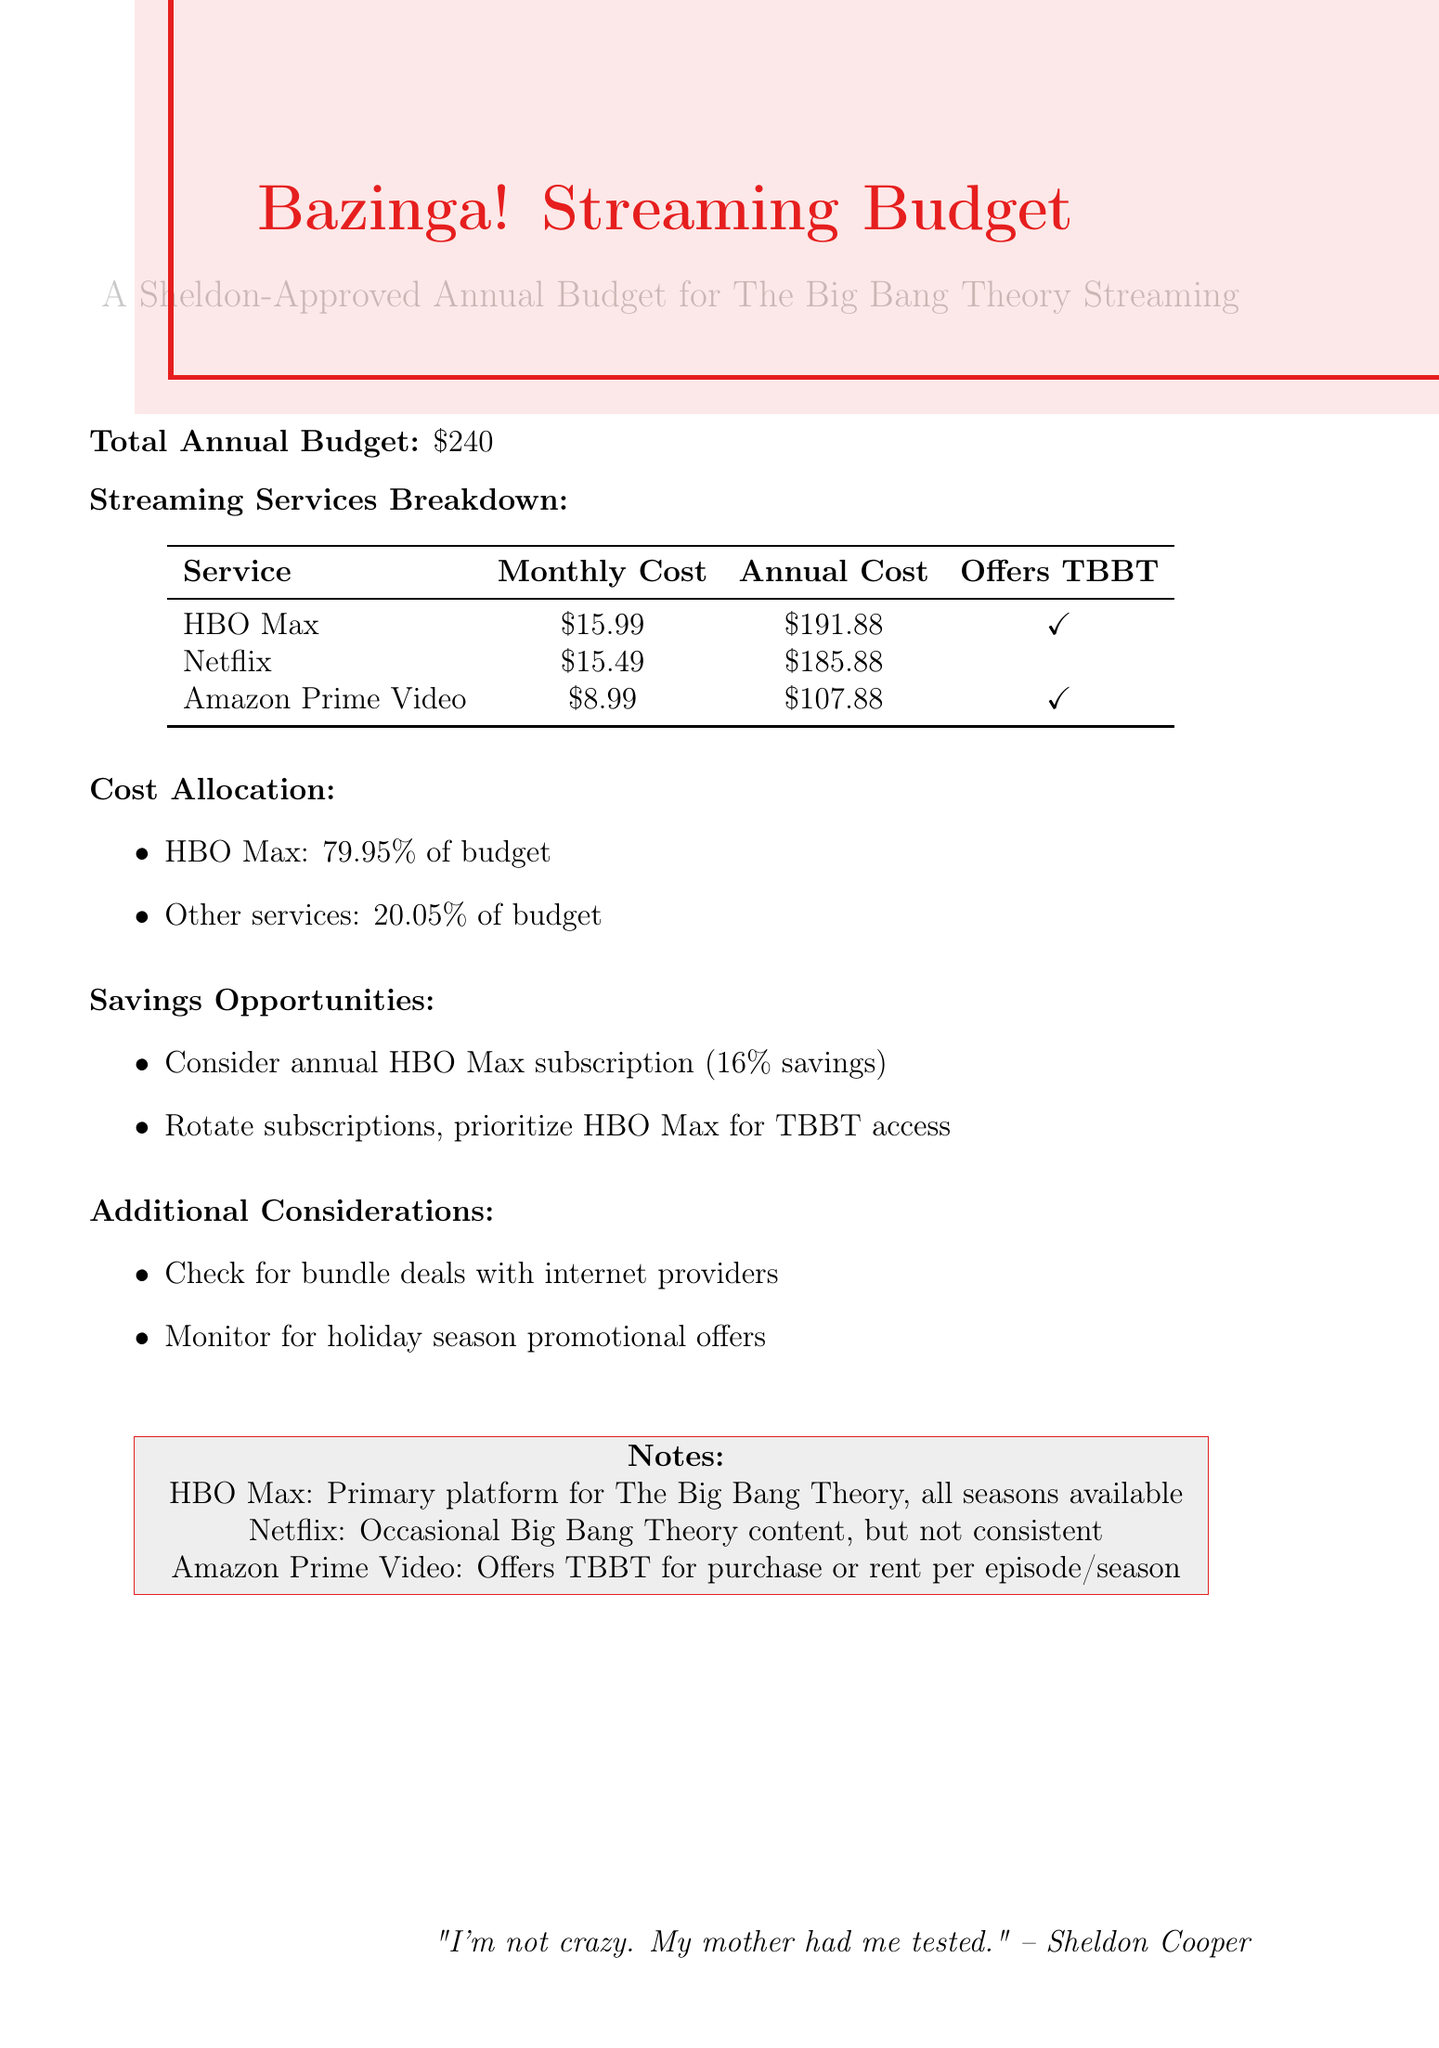What is the total annual budget? The total annual budget is explicitly stated in the document.
Answer: $240 Which streaming service has the highest annual cost? The service with the highest annual cost is identified in the breakdown section.
Answer: HBO Max Does Netflix offer The Big Bang Theory? The document clearly indicates whether each service offers The Big Bang Theory.
Answer: No What percentage of the budget is allocated to HBO Max? The percentage allocated to HBO Max is mentioned in the cost allocation section.
Answer: 79.95% What is one suggested way to save on subscriptions? The document lists potential savings opportunities.
Answer: Consider annual subscription for HBO Max to save 16% What is the monthly cost of Amazon Prime Video? The monthly cost of each streaming service is provided for reference.
Answer: $8.99 How many streaming services offer The Big Bang Theory? The document specifies how many services provide access to the show.
Answer: Two What is mentioned as a consideration for subscription deals? The additional considerations section lists practical suggestions.
Answer: Check for bundle deals with internet service providers 